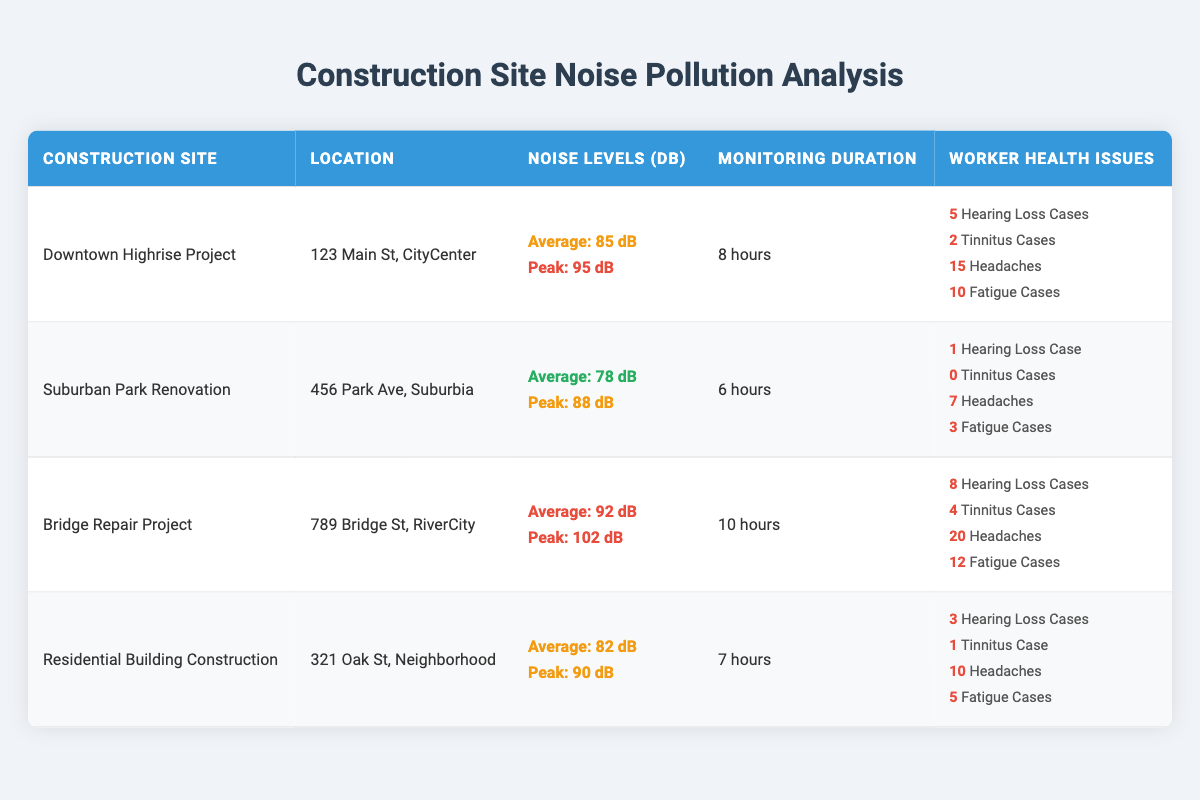What is the average noise level in decibels for the Downtown Highrise Project? The table states that the average noise level for the Downtown Highrise Project is 85 dB, which can be found directly under the "Noise Levels (dB)" column in the row for that construction site.
Answer: 85 dB How many cases of tinnitus were reported at the Bridge Repair Project? The table shows that there were 4 cases of tinnitus reported at the Bridge Repair Project, which is detailed in the row related to that project under the "Worker Health Issues" column.
Answer: 4 What construction site had the highest peak noise level? By examining the "Peak Noise Level" entries in the table, the Bridge Repair Project has the highest peak noise level at 102 dB, compared to the others that range from 88 dB to 95 dB.
Answer: Bridge Repair Project What is the total number of headache cases reported across all construction sites? To find the total headaches reported, sum the individual cases from each site: 15 (Downtown) + 7 (Suburban) + 20 (Bridge) + 10 (Residential) = 52. This combines data from all four projects, giving a total headache case count.
Answer: 52 Does the Suburban Park Renovation report any cases of tinnitus? The table indicates that the Suburban Park Renovation reports 0 cases of tinnitus, which can be checked directly in its corresponding row under "Worker Health Issues."
Answer: No What is the average monitoring duration for all construction sites? To calculate the average monitoring duration: (8 + 6 + 10 + 7) = 31 hours, and then divide by the number of sites (4): 31/4 = 7.75 hours. This average is obtained by summing the durations listed and dividing by the total number of projects.
Answer: 7.75 hours Which construction site had the highest number of reported hearing loss cases? The Bridge Repair Project had the highest number of reported hearing loss cases, with 8 cases, as indicated in the "Worker Health Issues" column for that site when cross-referencing the data.
Answer: Bridge Repair Project What is the difference in average noise levels between the Downtown Highrise Project and Residential Building Construction? Calculate the difference by subtracting the average noise level of Residential Building Construction (82 dB) from that of Downtown Highrise Project (85 dB): 85 - 82 = 3 dB, showing a direct comparison of the average noise levels.
Answer: 3 dB How many construction sites reported more than 10 cases of headaches? By inspecting the table, only the Bridge Repair Project reported 20 cases of headaches, while the others reported fewer than 10, therefore the result is 1 site reporting more than 10 headaches.
Answer: 1 